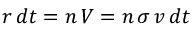Convert formula to latex. <formula><loc_0><loc_0><loc_500><loc_500>r \, d t = n \, V = n \, \sigma \, v \, d t</formula> 